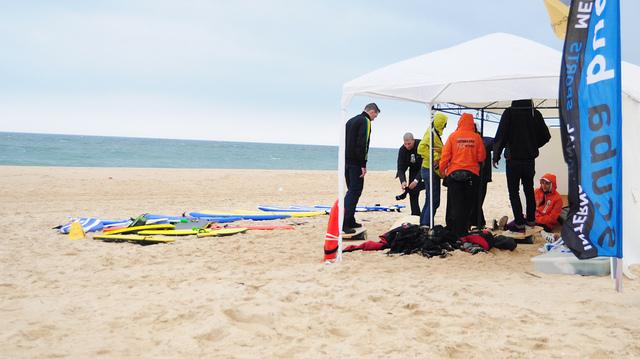What are they doing under the canopy? talking 